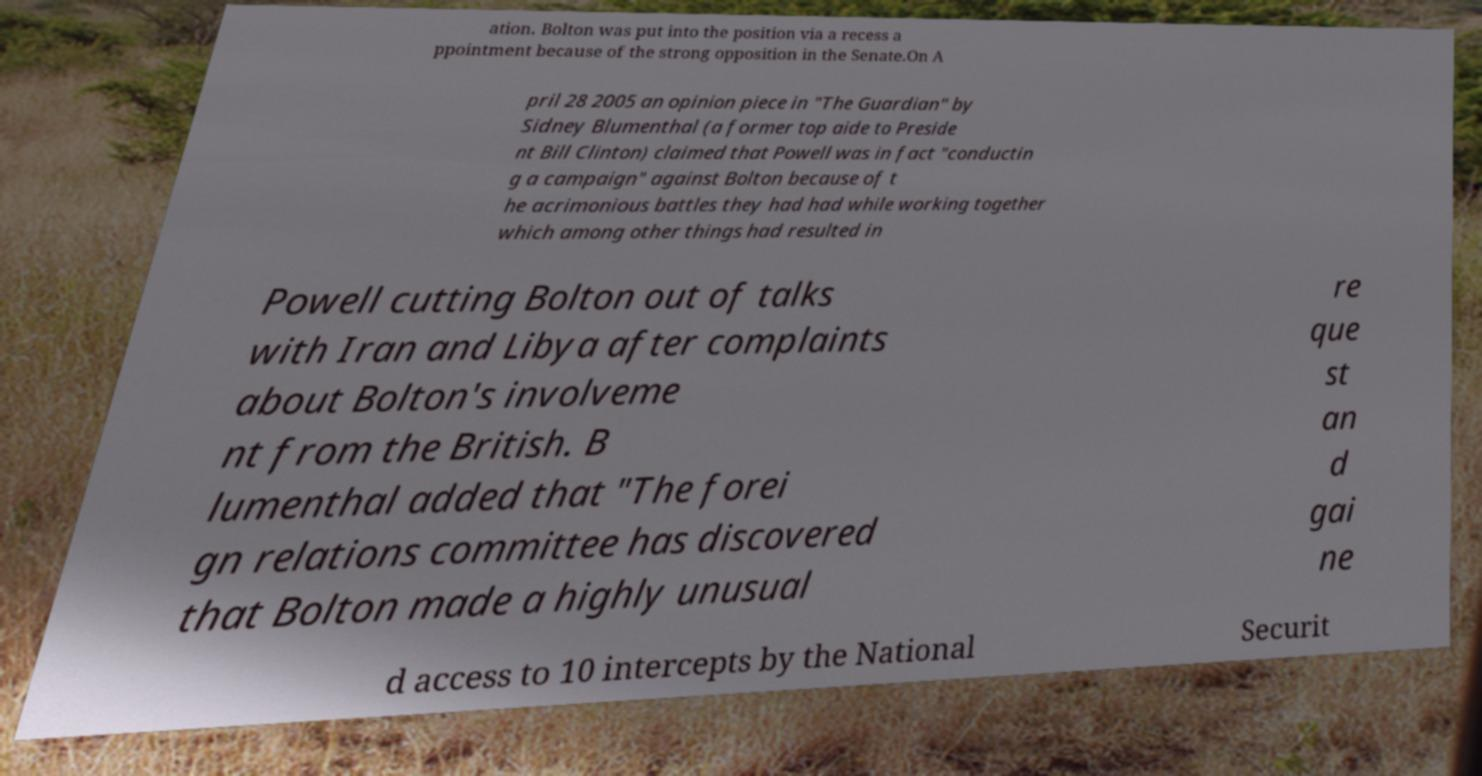Please read and relay the text visible in this image. What does it say? ation. Bolton was put into the position via a recess a ppointment because of the strong opposition in the Senate.On A pril 28 2005 an opinion piece in "The Guardian" by Sidney Blumenthal (a former top aide to Preside nt Bill Clinton) claimed that Powell was in fact "conductin g a campaign" against Bolton because of t he acrimonious battles they had had while working together which among other things had resulted in Powell cutting Bolton out of talks with Iran and Libya after complaints about Bolton's involveme nt from the British. B lumenthal added that "The forei gn relations committee has discovered that Bolton made a highly unusual re que st an d gai ne d access to 10 intercepts by the National Securit 